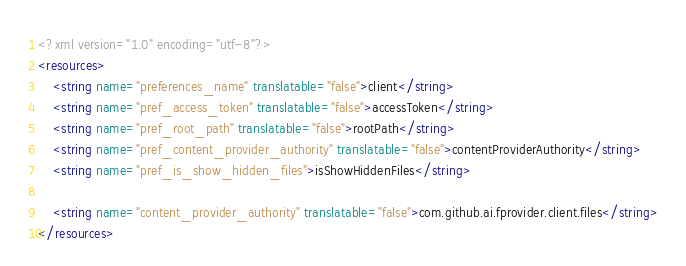<code> <loc_0><loc_0><loc_500><loc_500><_XML_><?xml version="1.0" encoding="utf-8"?>
<resources>
    <string name="preferences_name" translatable="false">client</string>
    <string name="pref_access_token" translatable="false">accessToken</string>
    <string name="pref_root_path" translatable="false">rootPath</string>
    <string name="pref_content_provider_authority" translatable="false">contentProviderAuthority</string>
    <string name="pref_is_show_hidden_files">isShowHiddenFiles</string>

    <string name="content_provider_authority" translatable="false">com.github.ai.fprovider.client.files</string>
</resources></code> 